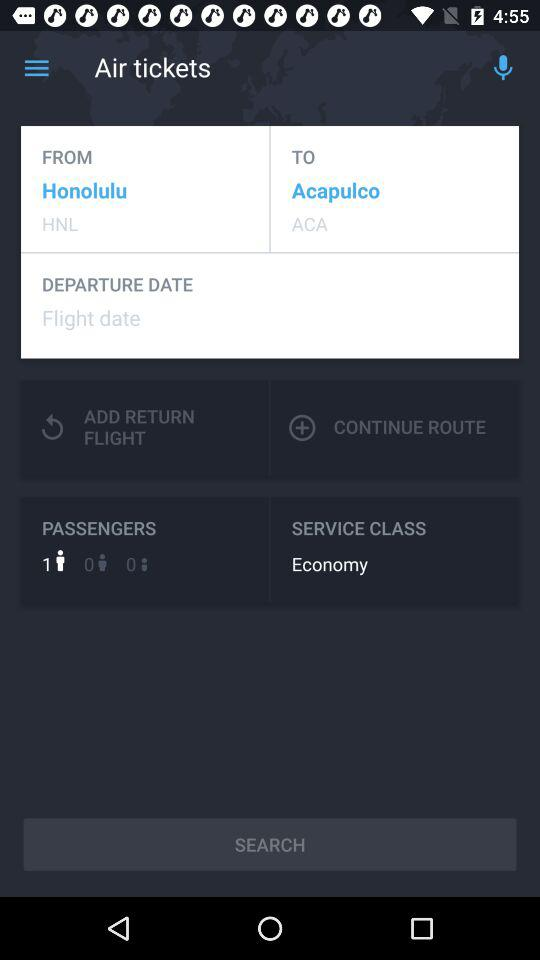How many more passengers are there than adults?
Answer the question using a single word or phrase. 1 